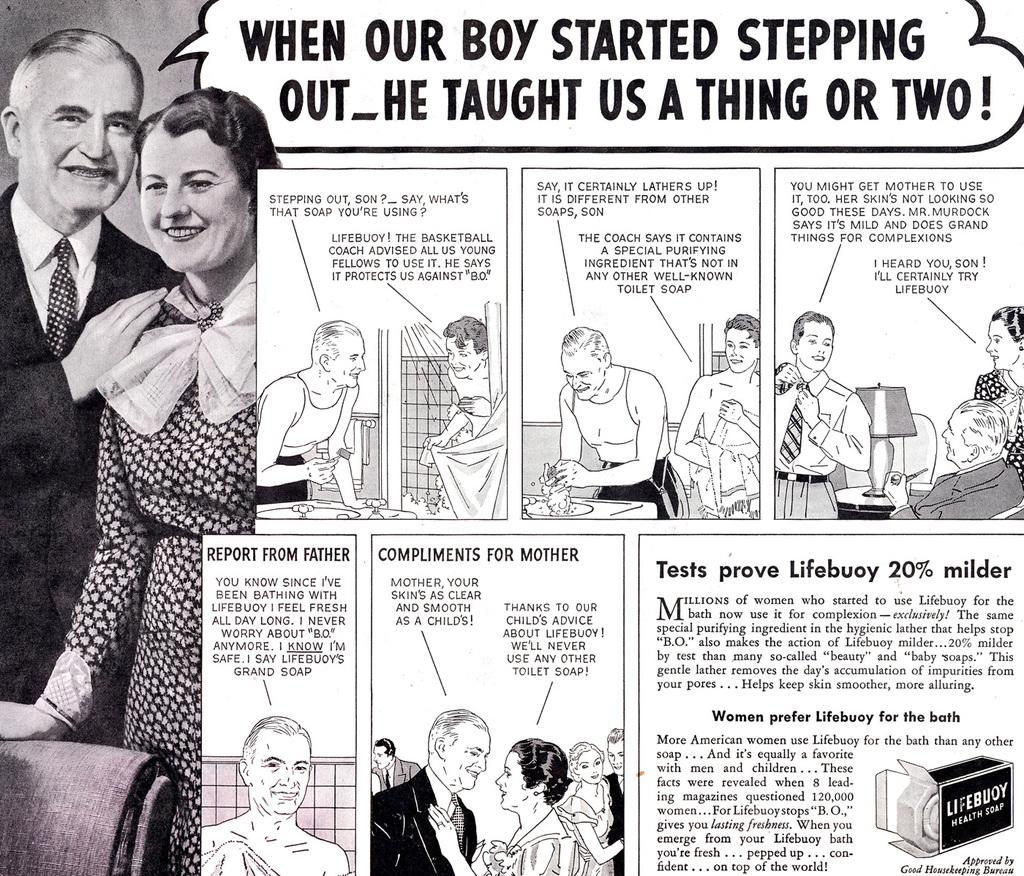Can you describe this image briefly? In this image there is a news paper clipping with a picture of a couple with some text and cartoon images on it. 